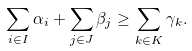Convert formula to latex. <formula><loc_0><loc_0><loc_500><loc_500>\sum _ { i \in I } \alpha _ { i } + \sum _ { j \in J } \beta _ { j } \geq \sum _ { k \in K } \gamma _ { k } .</formula> 